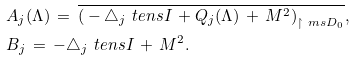Convert formula to latex. <formula><loc_0><loc_0><loc_500><loc_500>& A _ { j } ( \Lambda ) \, = \, \overline { \left ( { } - \triangle _ { j } \ t e n s I \, + Q _ { j } ( \Lambda ) \, + \, M ^ { 2 } \right ) _ { \upharpoonright \ m s { D } _ { 0 } } } , \\ & B _ { j } \, = \, - \triangle _ { j } \ t e n s I \, + \, M ^ { 2 } .</formula> 